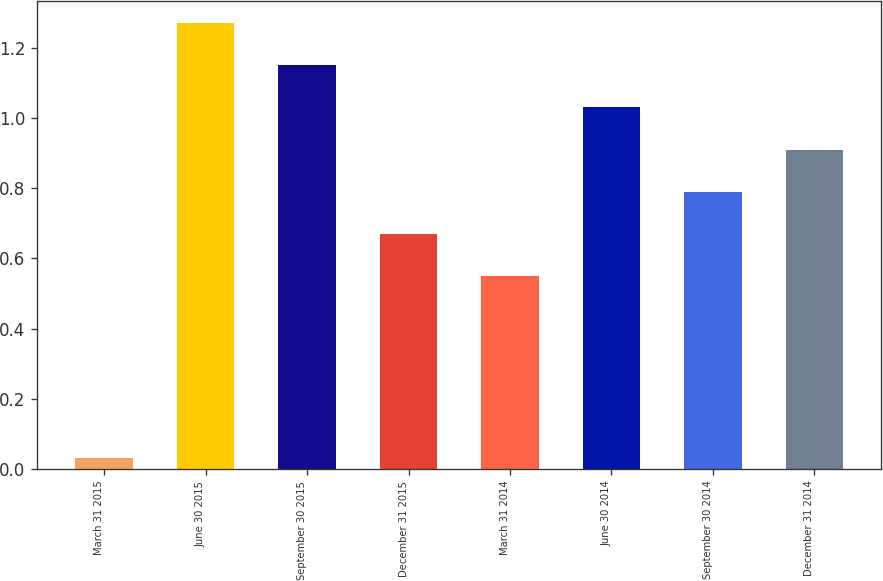Convert chart to OTSL. <chart><loc_0><loc_0><loc_500><loc_500><bar_chart><fcel>March 31 2015<fcel>June 30 2015<fcel>September 30 2015<fcel>December 31 2015<fcel>March 31 2014<fcel>June 30 2014<fcel>September 30 2014<fcel>December 31 2014<nl><fcel>0.03<fcel>1.27<fcel>1.15<fcel>0.67<fcel>0.55<fcel>1.03<fcel>0.79<fcel>0.91<nl></chart> 